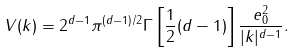Convert formula to latex. <formula><loc_0><loc_0><loc_500><loc_500>V ( { k } ) = 2 ^ { d - 1 } \pi ^ { ( d - 1 ) / 2 } \Gamma \left [ \frac { 1 } { 2 } ( d - 1 ) \right ] \frac { e _ { 0 } ^ { 2 } } { | { k } | ^ { d - 1 } } .</formula> 